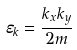<formula> <loc_0><loc_0><loc_500><loc_500>\varepsilon _ { k } = \frac { k _ { x } k _ { y } } { 2 m }</formula> 